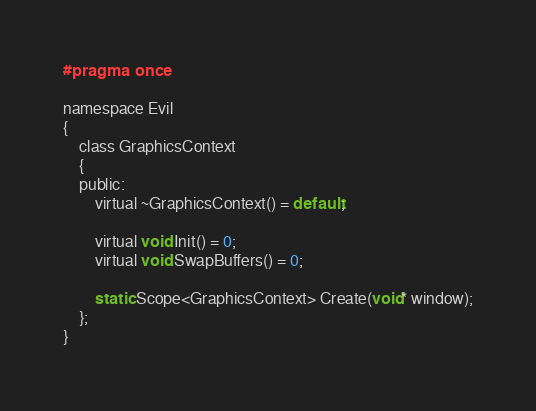<code> <loc_0><loc_0><loc_500><loc_500><_C_>#pragma once

namespace Evil
{
	class GraphicsContext
	{
	public:
		virtual ~GraphicsContext() = default;

		virtual void Init() = 0;
		virtual void SwapBuffers() = 0;

		static Scope<GraphicsContext> Create(void* window);
	};
}</code> 